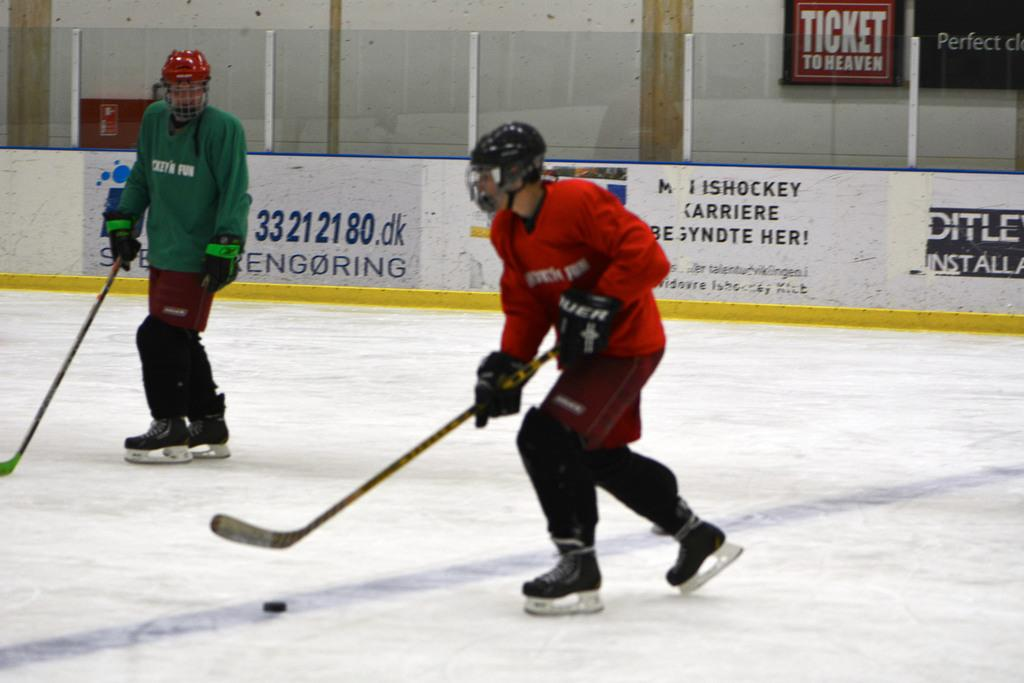<image>
Relay a brief, clear account of the picture shown. Two hockey players are on the rink in front of signs for Ticket to Heaven and others. 